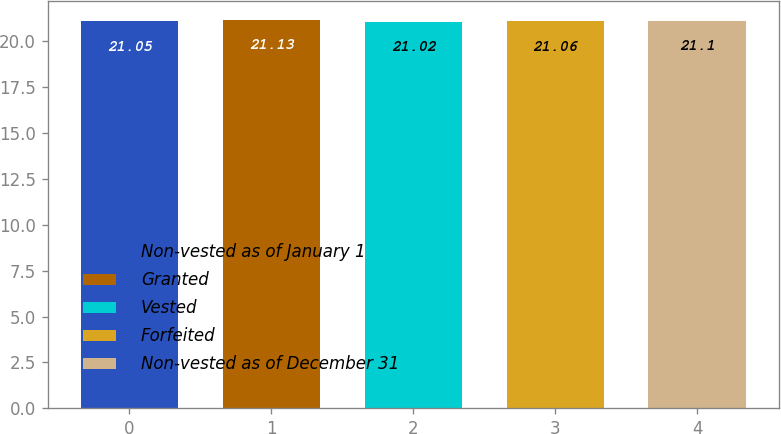<chart> <loc_0><loc_0><loc_500><loc_500><bar_chart><fcel>Non-vested as of January 1<fcel>Granted<fcel>Vested<fcel>Forfeited<fcel>Non-vested as of December 31<nl><fcel>21.05<fcel>21.13<fcel>21.02<fcel>21.06<fcel>21.1<nl></chart> 